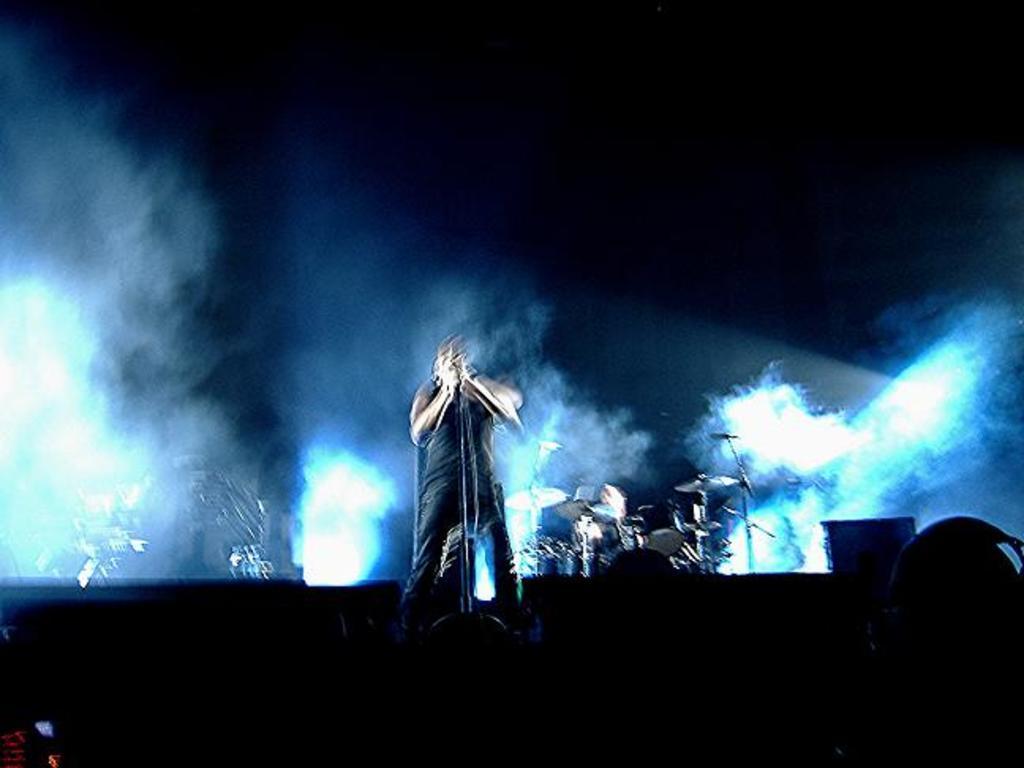How would you summarize this image in a sentence or two? There is a person in black color dress, standing and holding an object, on the stage in front of a stand. In the background, there are drums, smoke and lights. And the background is dark in color. 